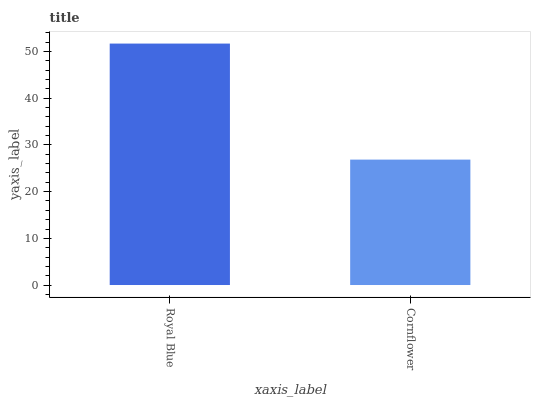Is Cornflower the minimum?
Answer yes or no. Yes. Is Royal Blue the maximum?
Answer yes or no. Yes. Is Cornflower the maximum?
Answer yes or no. No. Is Royal Blue greater than Cornflower?
Answer yes or no. Yes. Is Cornflower less than Royal Blue?
Answer yes or no. Yes. Is Cornflower greater than Royal Blue?
Answer yes or no. No. Is Royal Blue less than Cornflower?
Answer yes or no. No. Is Royal Blue the high median?
Answer yes or no. Yes. Is Cornflower the low median?
Answer yes or no. Yes. Is Cornflower the high median?
Answer yes or no. No. Is Royal Blue the low median?
Answer yes or no. No. 